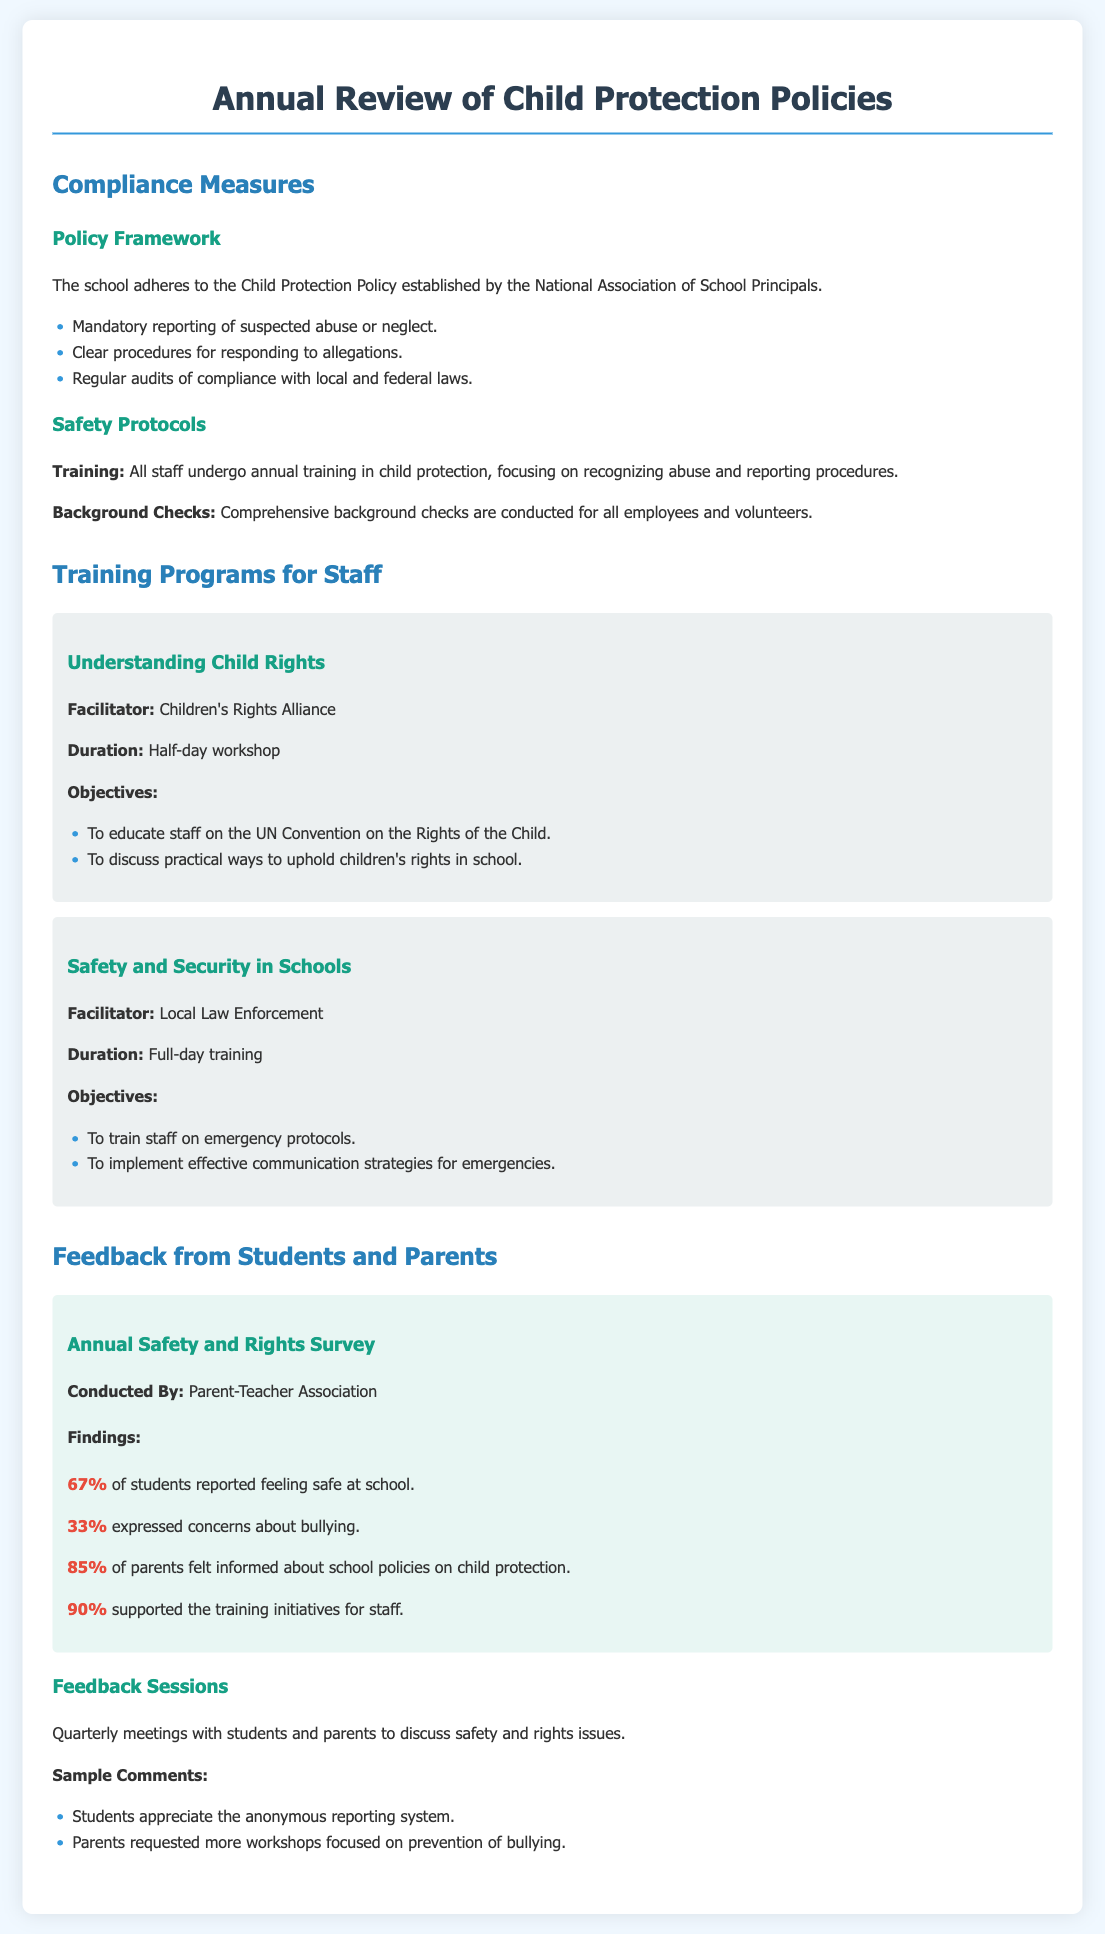what is the percentage of students who feel safe at school? The document states that 67% of students reported feeling safe at school.
Answer: 67% who conducts the Annual Safety and Rights Survey? The survey is conducted by the Parent-Teacher Association.
Answer: Parent-Teacher Association how many workshops focused on child rights were mentioned? There is one workshop titled "Understanding Child Rights."
Answer: One what is the duration of the "Safety and Security in Schools" training? The duration of this training is a full-day.
Answer: Full-day what percentage of parents felt informed about school policies on child protection? The document indicates that 85% of parents felt informed about such policies.
Answer: 85% what are the two main objectives of the "Understanding Child Rights" workshop? The objectives are to educate staff on the UN Convention on the Rights of the Child and to discuss practical ways to uphold children's rights in school.
Answer: Educate staff on the UN Convention and discuss ways to uphold rights what proportion of students expressed concerns about bullying? The document mentions that 33% expressed concerns about bullying.
Answer: 33% how frequently are feedback sessions with students and parents held? Feedback sessions are held quarterly.
Answer: Quarterly what is one of the sample comments from students regarding safety? Students appreciate the anonymous reporting system.
Answer: Anonymous reporting system 